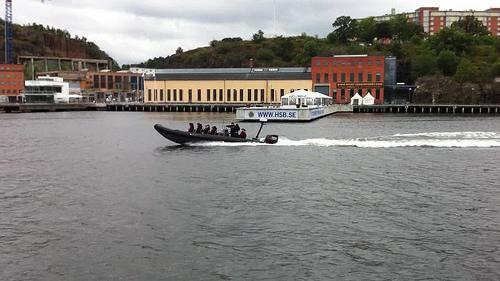How many people in the boat are wearing life jackets?
Give a very brief answer. 5. 